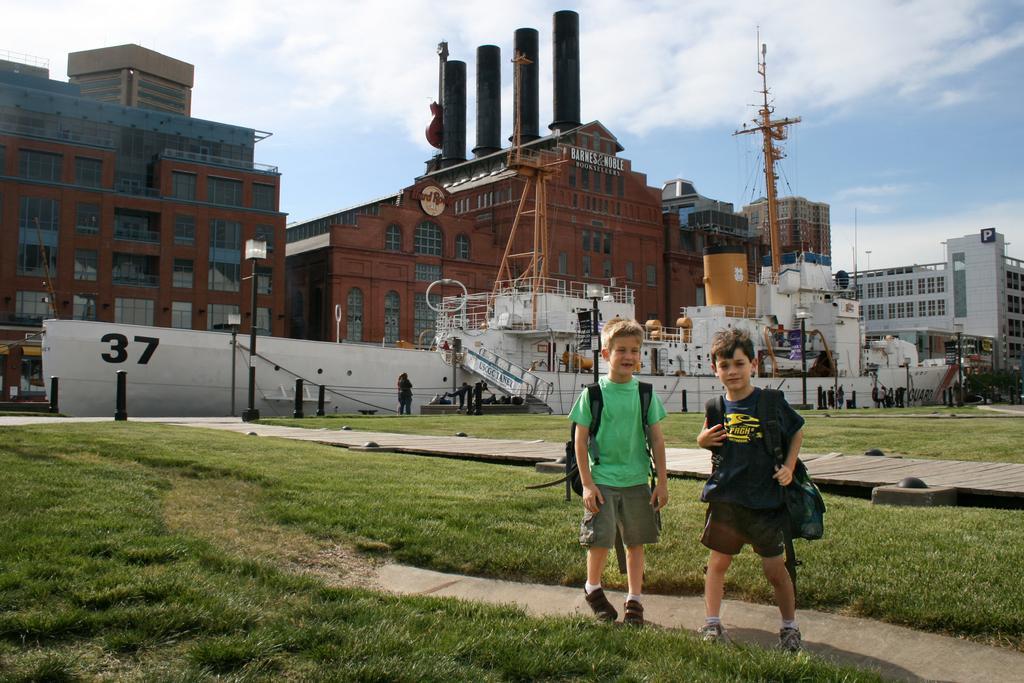Can you describe this image briefly? In this image, we can see some buildings and ships. There are kids at the bottom of the image standing and wearing bags. There is a sky at the top of the image. 